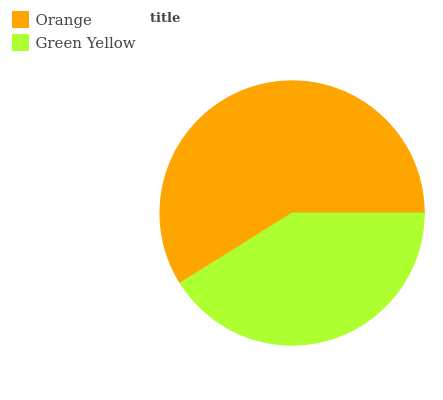Is Green Yellow the minimum?
Answer yes or no. Yes. Is Orange the maximum?
Answer yes or no. Yes. Is Green Yellow the maximum?
Answer yes or no. No. Is Orange greater than Green Yellow?
Answer yes or no. Yes. Is Green Yellow less than Orange?
Answer yes or no. Yes. Is Green Yellow greater than Orange?
Answer yes or no. No. Is Orange less than Green Yellow?
Answer yes or no. No. Is Orange the high median?
Answer yes or no. Yes. Is Green Yellow the low median?
Answer yes or no. Yes. Is Green Yellow the high median?
Answer yes or no. No. Is Orange the low median?
Answer yes or no. No. 